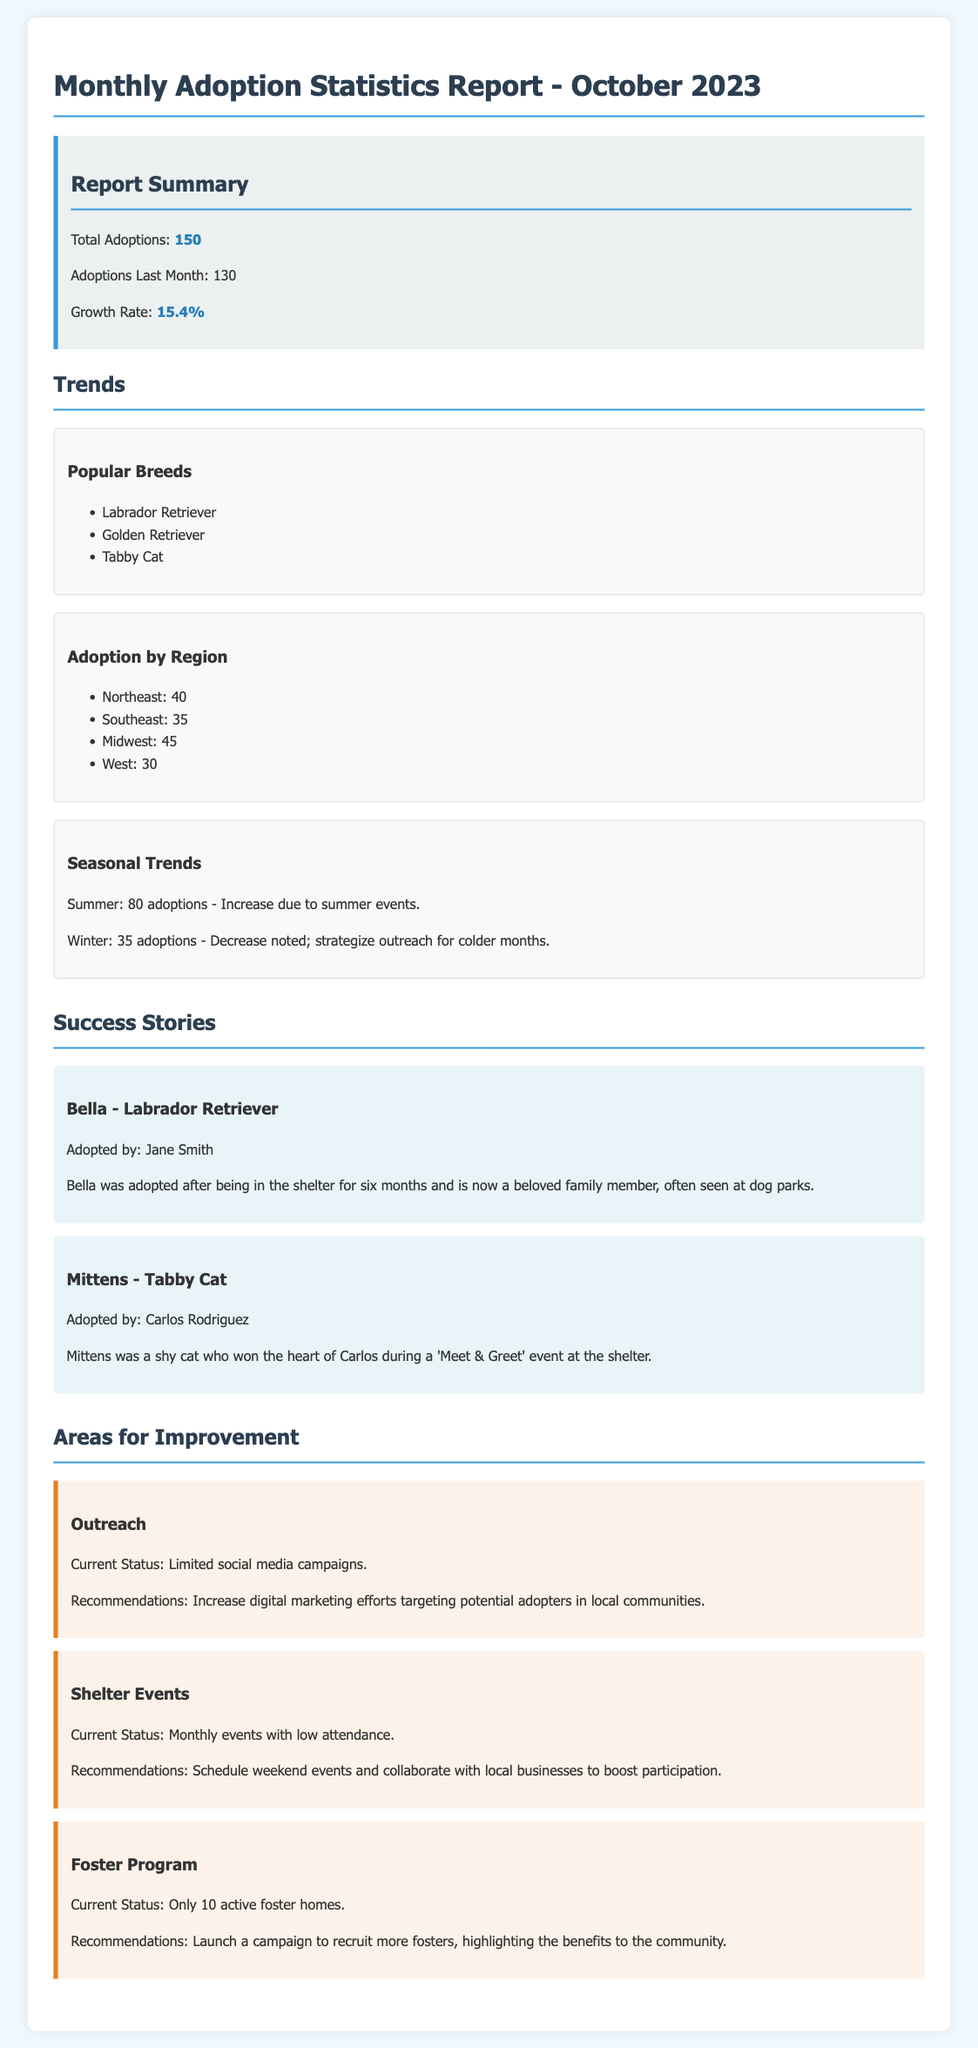What is the total number of adoptions in October 2023? The total number of adoptions is stated in the report summary, which shows 150 adoptions.
Answer: 150 What was the growth rate compared to last month? The growth rate is specified in the report summary and is noted as 15.4%.
Answer: 15.4% Which breed had the highest number of adoptions? The popular breeds section lists Labrador Retriever as one of the top breeds, implying its popularity.
Answer: Labrador Retriever How many adoptions were reported in the Northeast region? The adoption by region section indicates 40 adoptions in the Northeast.
Answer: 40 What is one key area identified for improvement in outreach? The report mentions limited social media campaigns as a current status for outreach improvements.
Answer: Limited social media campaigns Who adopted Bella? Bella was adopted by Jane Smith, as stated in her success story.
Answer: Jane Smith What seasonal trend is observed during winter? The report mentions a decrease noted during winter, indicating challenges in adoptions.
Answer: Decrease noted How many active foster homes are currently available? The areas for improvement section reports that there are only 10 active foster homes.
Answer: 10 What recommendation is suggested for shelter events? It is recommended to schedule weekend events and collaborate with local businesses to boost participation.
Answer: Schedule weekend events and collaborate with local businesses 